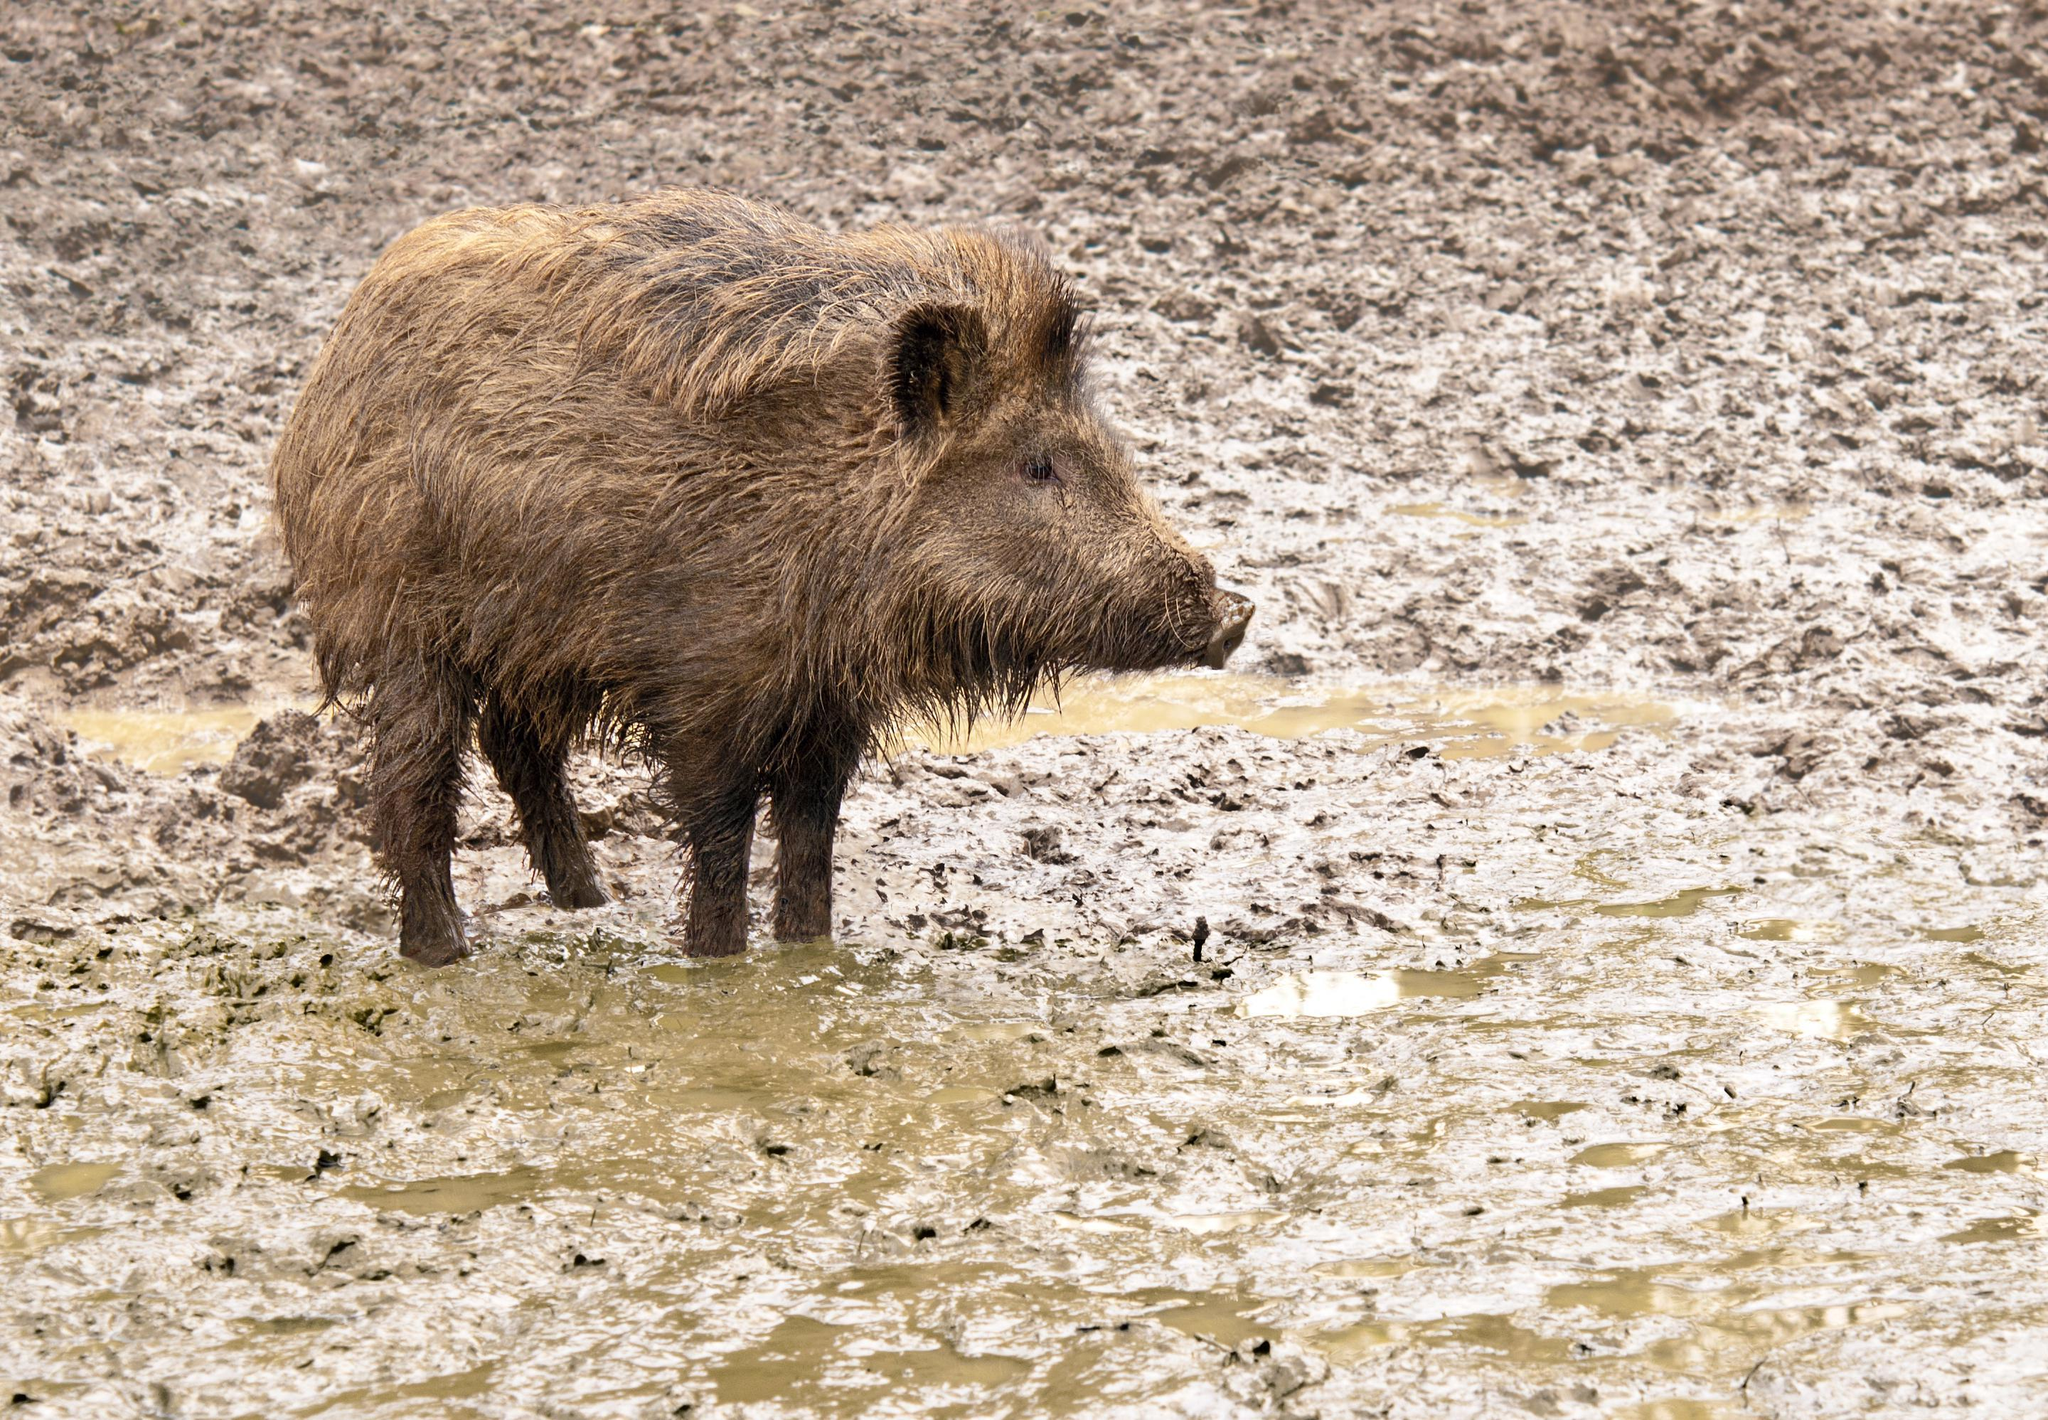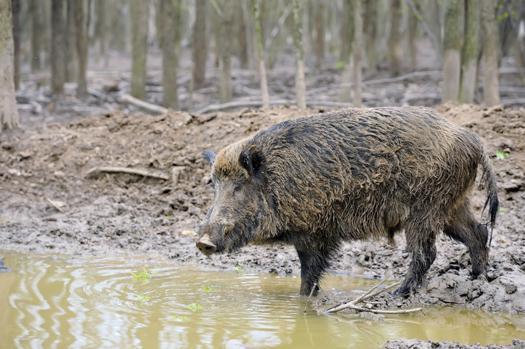The first image is the image on the left, the second image is the image on the right. Given the left and right images, does the statement "In at least one image there is a hog in the mud whose body is facing left while they rest." hold true? Answer yes or no. No. 